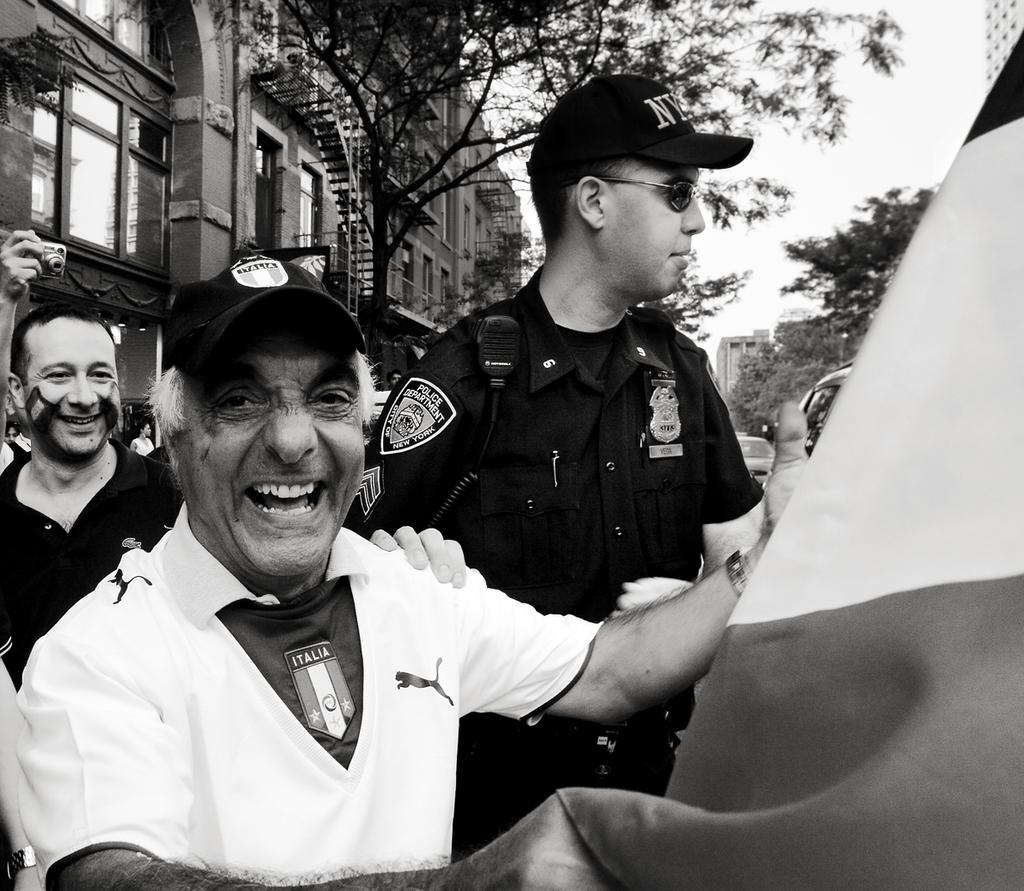How many people are in the image? There is a group of people in the image, but the exact number is not specified. What is the facial expression of the people in the image? The people in the image are smiling. What is the man holding in the image? The man is holding a flag in the image. What can be seen in the background of the image? There is a camera, buildings with windows, trees, and the sky visible in the background of the image. How many feet are visible in the image? There is no specific mention of feet in the image, so it is not possible to determine the number of feet visible. 